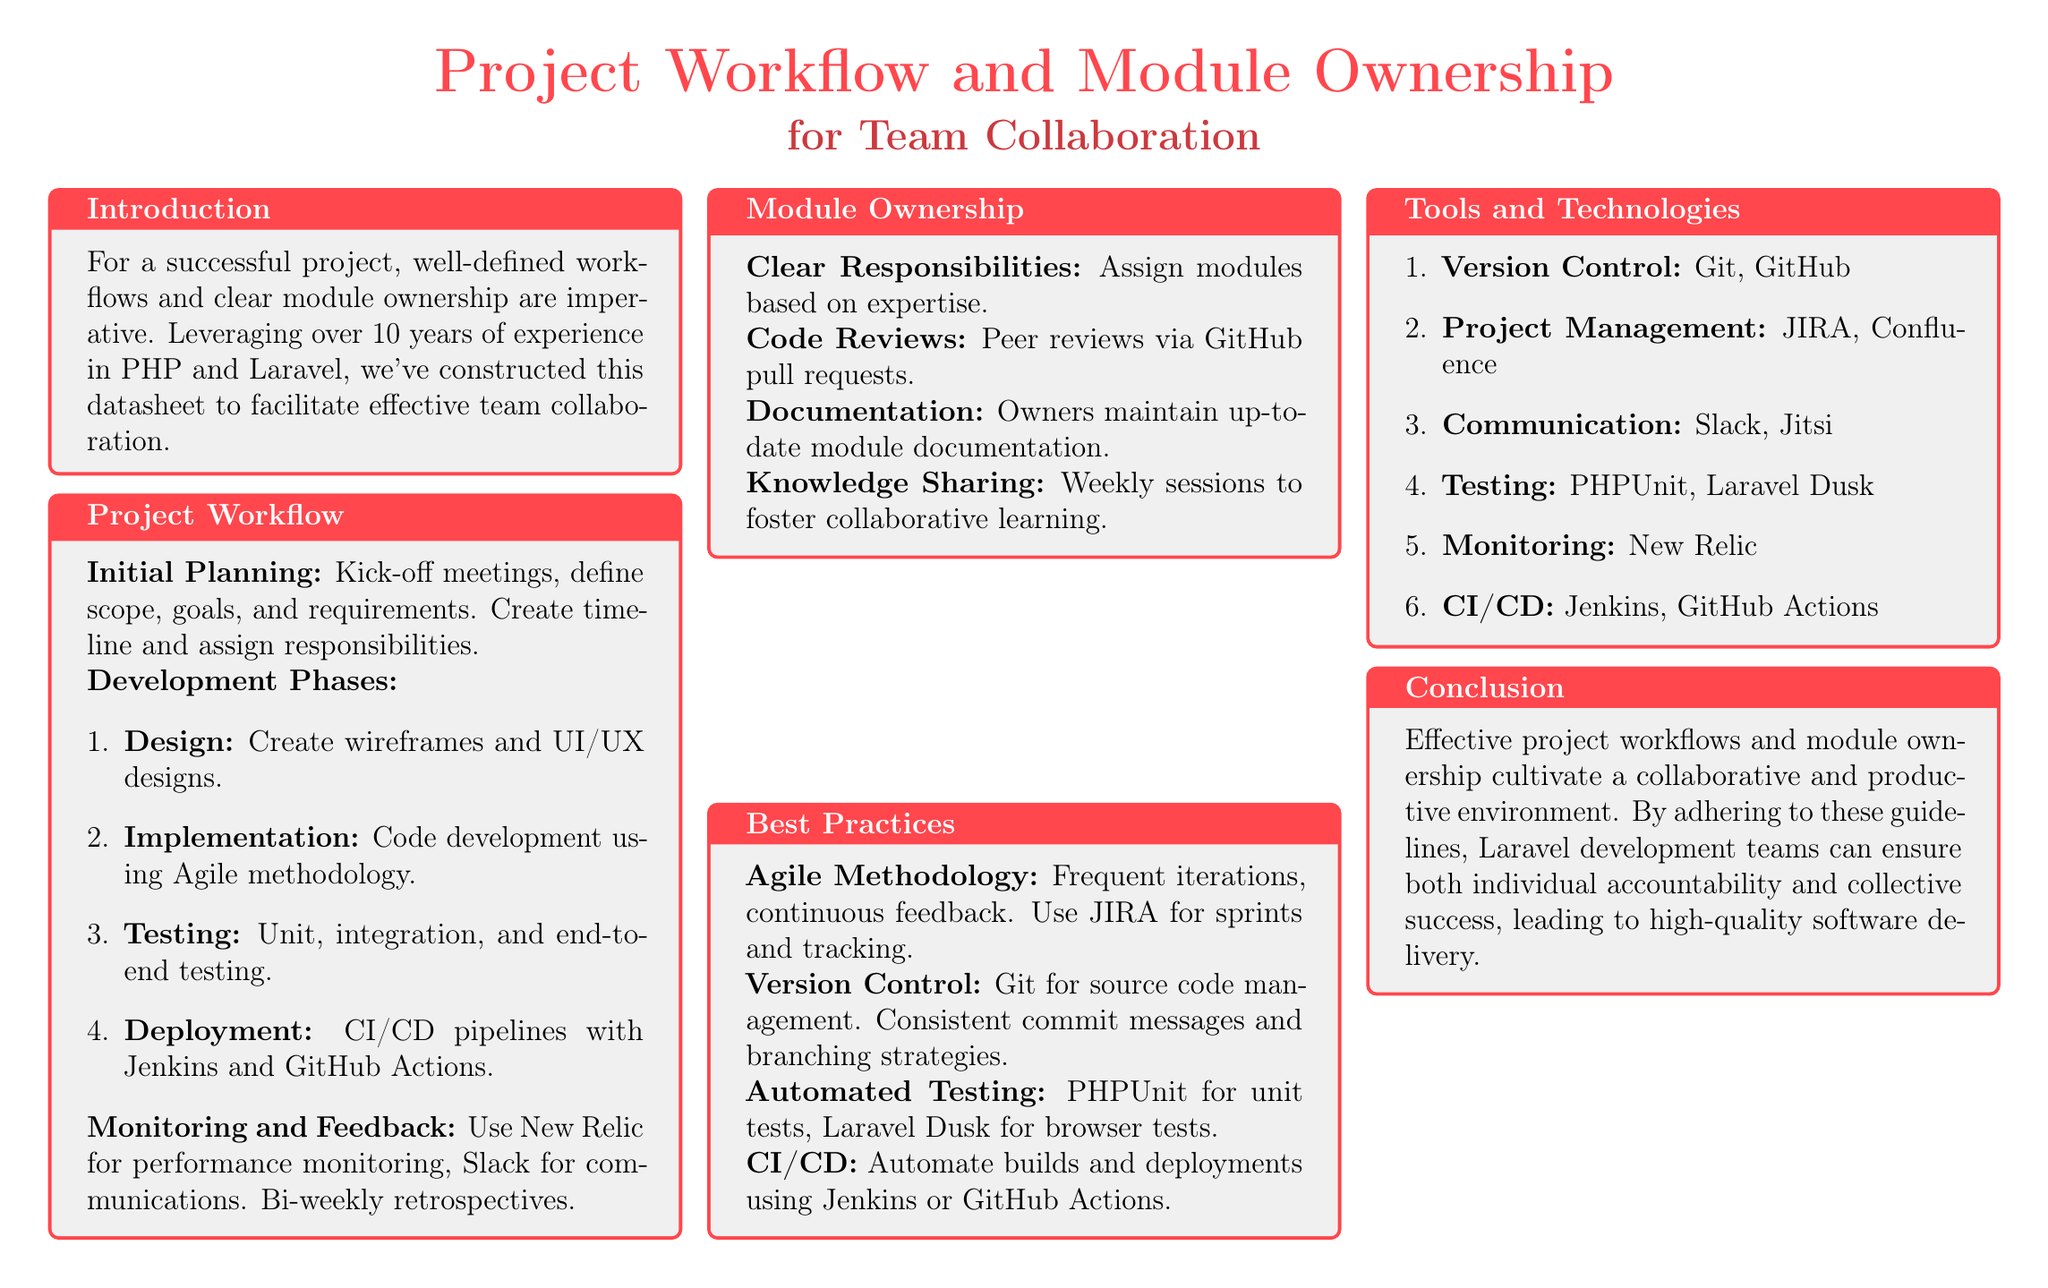What is the title of the document? The title of the document is prominently displayed at the top of the rendered content.
Answer: Project Workflow and Module Ownership What are the tools used for project management? The document lists several tools in the section dedicated to tools and technologies, highlighting their purpose in project management.
Answer: JIRA, Confluence How many development phases are outlined? The development phase section clearly lists a sequence of phases that developers must follow, and counting them provides the answer.
Answer: Four What monitoring tool is mentioned in the document? The document specifies a tool used for performance monitoring under the monitoring and feedback section.
Answer: New Relic What is the main objective of module ownership? The document mentions key objectives related to module ownership that ensure clarity and productivity in project workflow.
Answer: Clear Responsibilities What methodology does the document encourage for development? The methodology section emphasizes a particular framework that guides the development process throughout the project lifecycle.
Answer: Agile Methodology How often should knowledge-sharing sessions occur? The module ownership section indicates a regular interval for sessions designed to promote collaborative learning among team members.
Answer: Weekly Which CI/CD tools are highlighted? The tools and technologies section provides a list, indicating specific tools relevant to continuous integration and deployment.
Answer: Jenkins, GitHub Actions What testing framework is mentioned for unit tests? The best practices section identifies a specific testing framework to ensure code reliability through unit testing.
Answer: PHPUnit 